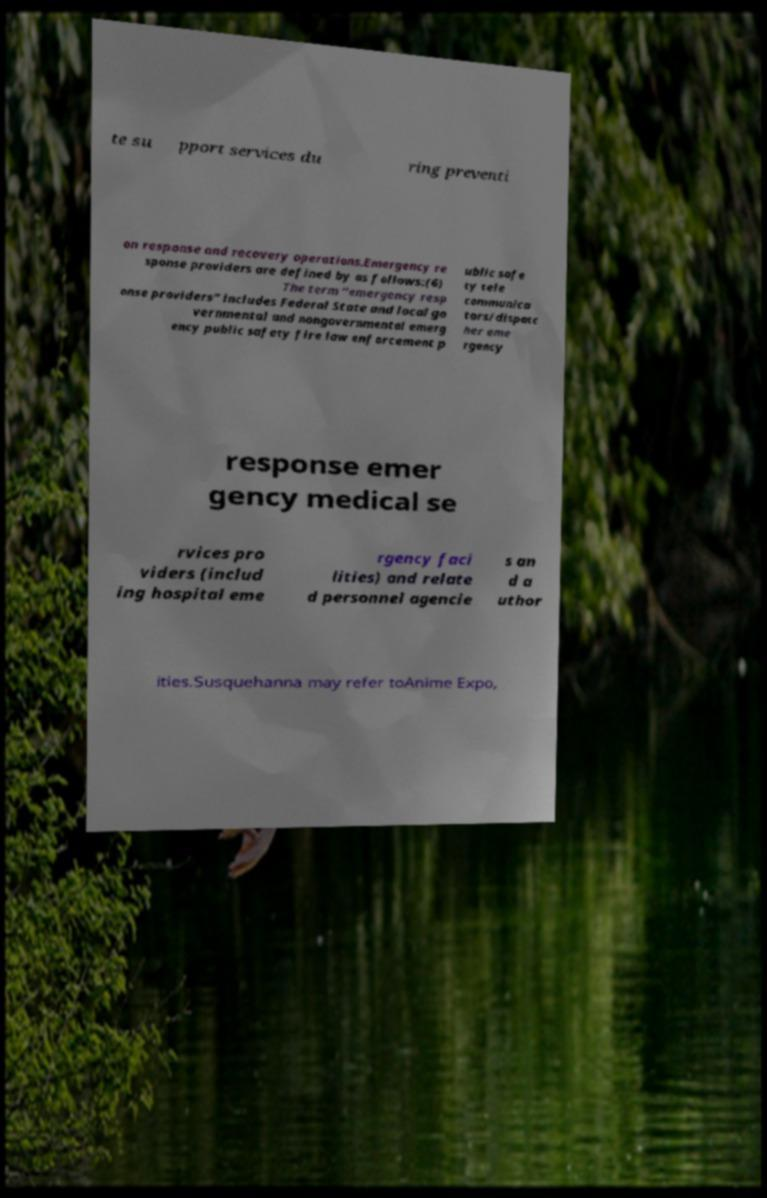There's text embedded in this image that I need extracted. Can you transcribe it verbatim? te su pport services du ring preventi on response and recovery operations.Emergency re sponse providers are defined by as follows:(6) The term “emergency resp onse providers” includes Federal State and local go vernmental and nongovernmental emerg ency public safety fire law enforcement p ublic safe ty tele communica tors/dispatc her eme rgency response emer gency medical se rvices pro viders (includ ing hospital eme rgency faci lities) and relate d personnel agencie s an d a uthor ities.Susquehanna may refer toAnime Expo, 